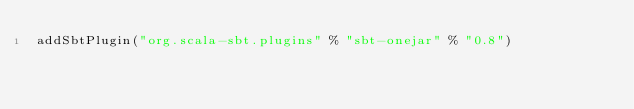<code> <loc_0><loc_0><loc_500><loc_500><_Scala_>addSbtPlugin("org.scala-sbt.plugins" % "sbt-onejar" % "0.8")
</code> 